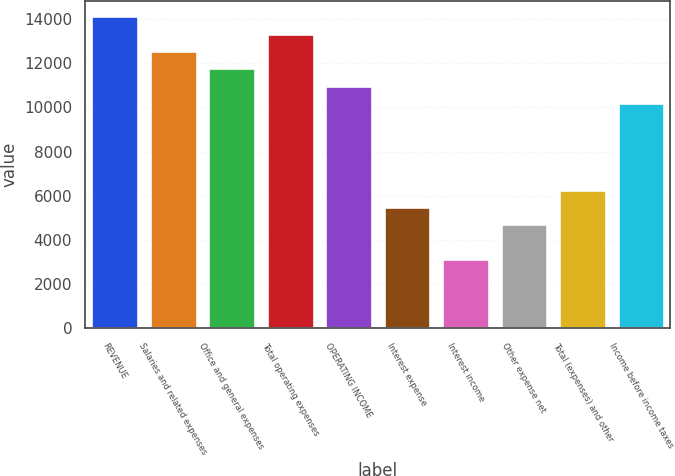Convert chart. <chart><loc_0><loc_0><loc_500><loc_500><bar_chart><fcel>REVENUE<fcel>Salaries and related expenses<fcel>Office and general expenses<fcel>Total operating expenses<fcel>OPERATING INCOME<fcel>Interest expense<fcel>Interest income<fcel>Other expense net<fcel>Total (expenses) and other<fcel>Income before income taxes<nl><fcel>14123.6<fcel>12554.4<fcel>11769.8<fcel>13339<fcel>10985.1<fcel>5492.71<fcel>3138.82<fcel>4708.08<fcel>6277.34<fcel>10200.5<nl></chart> 